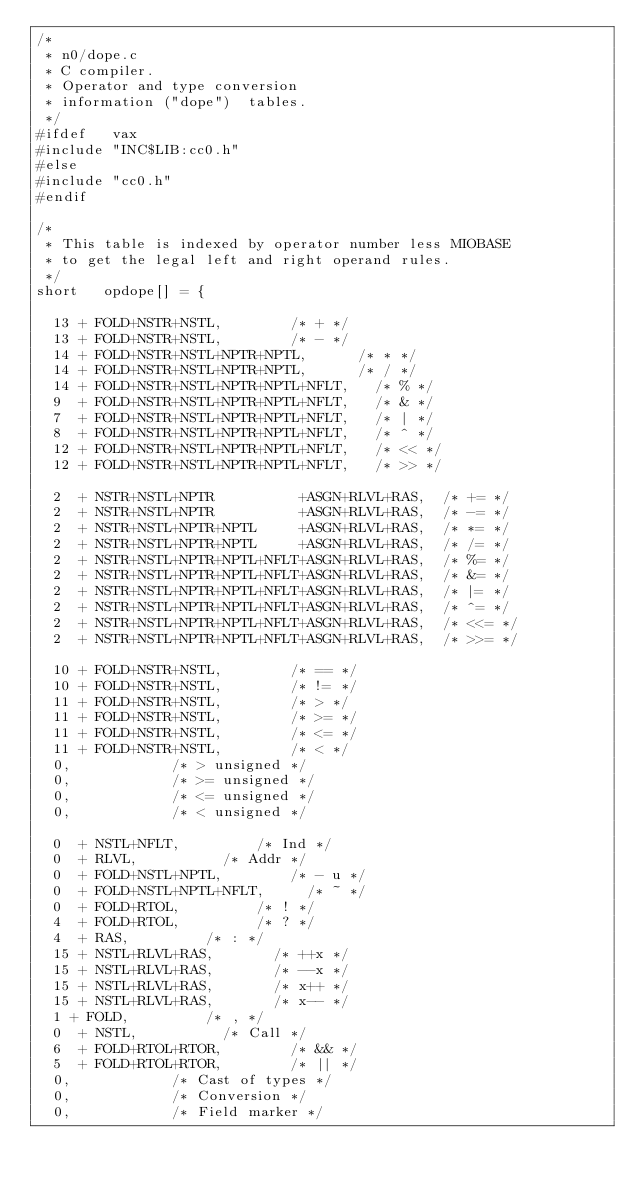Convert code to text. <code><loc_0><loc_0><loc_500><loc_500><_C_>/*
 * n0/dope.c
 * C compiler.
 * Operator and type conversion
 * information ("dope")  tables.
 */
#ifdef   vax
#include "INC$LIB:cc0.h"
#else
#include "cc0.h"
#endif

/*
 * This table is indexed by operator number less MIOBASE
 * to get the legal left and right operand rules.
 */
short   opdope[] = {

	13 + FOLD+NSTR+NSTL,				/* + */
	13 + FOLD+NSTR+NSTL,				/* - */
	14 + FOLD+NSTR+NSTL+NPTR+NPTL,			/* * */
	14 + FOLD+NSTR+NSTL+NPTR+NPTL,			/* / */
	14 + FOLD+NSTR+NSTL+NPTR+NPTL+NFLT,		/* % */
	9  + FOLD+NSTR+NSTL+NPTR+NPTL+NFLT,		/* & */
	7  + FOLD+NSTR+NSTL+NPTR+NPTL+NFLT,		/* | */
	8  + FOLD+NSTR+NSTL+NPTR+NPTL+NFLT,		/* ^ */
	12 + FOLD+NSTR+NSTL+NPTR+NPTL+NFLT,		/* << */
	12 + FOLD+NSTR+NSTL+NPTR+NPTL+NFLT,		/* >> */

	2  + NSTR+NSTL+NPTR          +ASGN+RLVL+RAS,	/* += */
	2  + NSTR+NSTL+NPTR          +ASGN+RLVL+RAS,	/* -= */
	2  + NSTR+NSTL+NPTR+NPTL     +ASGN+RLVL+RAS,	/* *= */
	2  + NSTR+NSTL+NPTR+NPTL     +ASGN+RLVL+RAS,	/* /= */
	2  + NSTR+NSTL+NPTR+NPTL+NFLT+ASGN+RLVL+RAS,	/* %= */
	2  + NSTR+NSTL+NPTR+NPTL+NFLT+ASGN+RLVL+RAS,	/* &= */
	2  + NSTR+NSTL+NPTR+NPTL+NFLT+ASGN+RLVL+RAS,	/* |= */
	2  + NSTR+NSTL+NPTR+NPTL+NFLT+ASGN+RLVL+RAS,	/* ^= */
	2  + NSTR+NSTL+NPTR+NPTL+NFLT+ASGN+RLVL+RAS,	/* <<= */
	2  + NSTR+NSTL+NPTR+NPTL+NFLT+ASGN+RLVL+RAS,	/* >>= */

	10 + FOLD+NSTR+NSTL,				/* == */
	10 + FOLD+NSTR+NSTL,				/* != */
	11 + FOLD+NSTR+NSTL,				/* > */
	11 + FOLD+NSTR+NSTL,				/* >= */
	11 + FOLD+NSTR+NSTL,				/* <= */
	11 + FOLD+NSTR+NSTL,				/* < */
	0,						/* > unsigned */
	0,						/* >= unsigned */
	0,						/* <= unsigned */
	0,						/* < unsigned */

	0  + NSTL+NFLT,					/* Ind */
	0  + RLVL,					/* Addr */
	0  + FOLD+NSTL+NPTL,				/* - u */
	0  + FOLD+NSTL+NPTL+NFLT,			/* ~ */
	0  + FOLD+RTOL,					/* ! */
	4  + FOLD+RTOL,					/* ? */
	4  + RAS,					/* : */
	15 + NSTL+RLVL+RAS,				/* ++x */
	15 + NSTL+RLVL+RAS,				/* --x */
	15 + NSTL+RLVL+RAS,				/* x++ */
	15 + NSTL+RLVL+RAS,				/* x-- */
	1 + FOLD,					/* , */
	0  + NSTL,					/* Call */
	6  + FOLD+RTOL+RTOR,				/* && */
	5  + FOLD+RTOL+RTOR,				/* || */
	0,						/* Cast of types */
	0,						/* Conversion */
	0,						/* Field marker */</code> 